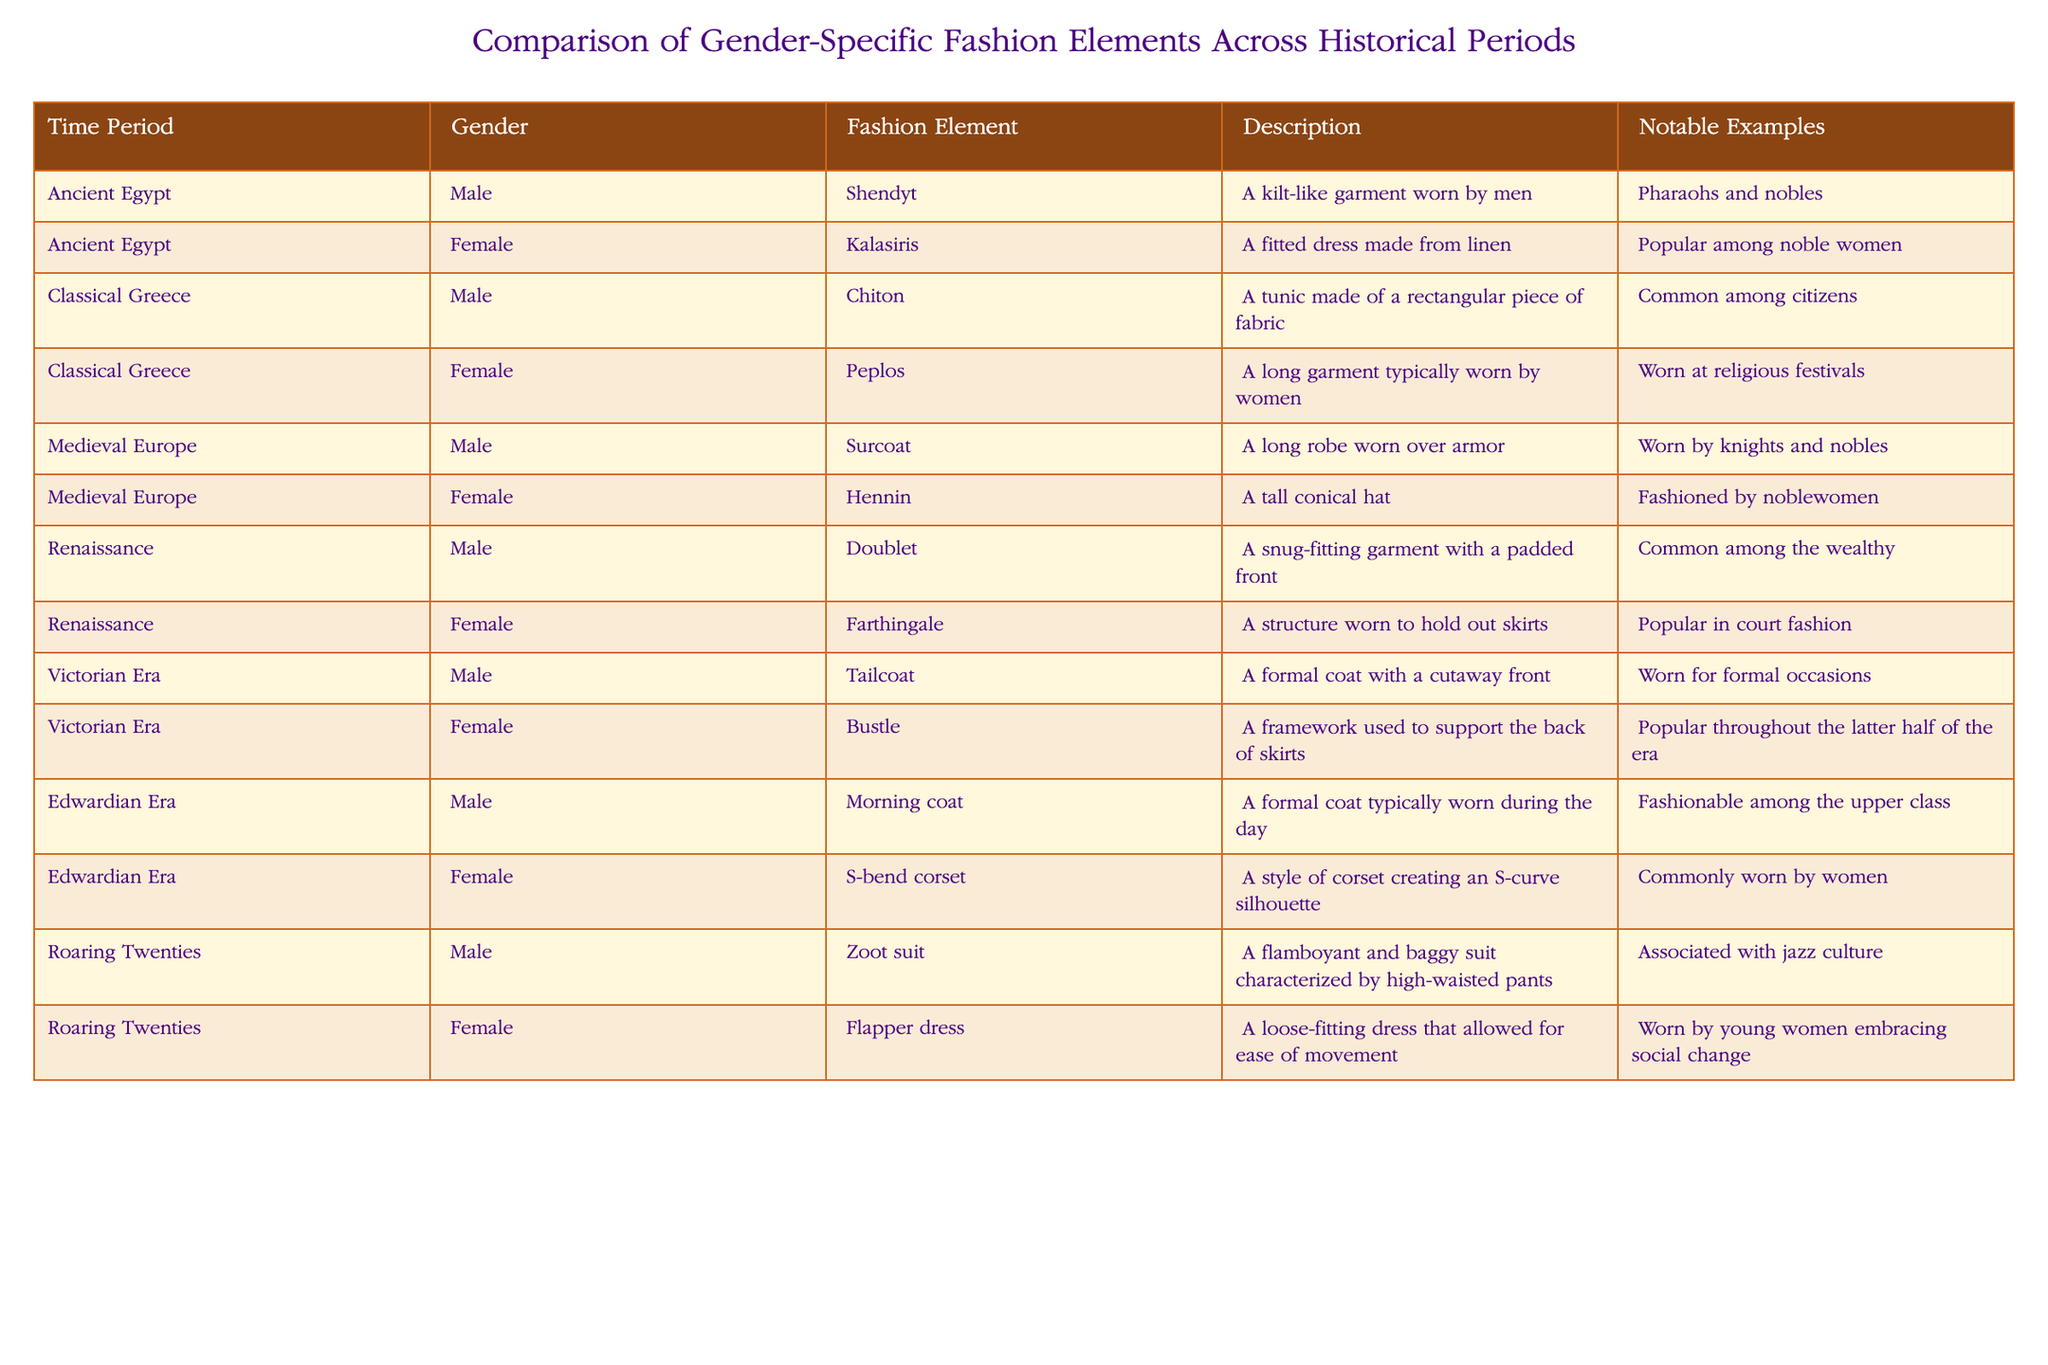What fashion element was worn by noblewomen in Ancient Egypt? According to the table, the fashion element worn by noblewomen in Ancient Egypt is the Kalasiris. This is directly stated in the table row corresponding to Ancient Egypt under the Female category.
Answer: Kalasiris Which gender wore a Zoot suit in the Roaring Twenties? From the table, it is clear that a Zoot suit was worn by males during the Roaring Twenties. This information is found in the row that represents the Roaring Twenties under the Male category.
Answer: Male How many unique fashion elements are listed for Medieval Europe? In the table, there are two entries specifically for Medieval Europe; one for male (Surcoat) and one for female (Hennin). Counting these gives a total of two unique fashion elements from that period.
Answer: 2 True or false: The Farthingale was a fashion element used by men during the Renaissance. The table indicates that the Farthingale was worn by females in the Renaissance. Since it is not associated with men, the statement is false.
Answer: False What is the main characteristic of the Flapper dress? The Flapper dress is described in the table as a loose-fitting dress that allowed for ease of movement, emphasizing its practicality and modern style during the Roaring Twenties.
Answer: Loose-fitting and allows ease of movement What are the notable examples of garments worn by the upper class in the Victorian Era? The table lists the Victorian Era fashion element for males as the Tailcoat and for females as the Bustle. Both were noted as worn for formal occasions and by people of higher social status, indicating their association with the upper class.
Answer: Tailcoat and Bustle How do the fashion elements for females compare between the Victorian Era and the Edwardian Era in terms of structure? In the Victorian Era, the Bustle is noted as a framework used to support skirts, whereas in the Edwardian Era, the S-bend corset is designed to create an S-curve silhouette. While both elements enhance a woman's shape, they do so in quite distinct ways, with the Bustle focusing on volume at the back and the S-bend corset focusing on creating specific body contours.
Answer: Different structural focus: Bustle for volume, S-bend corset for contour What fashion element is associated with jazz culture during the Roaring Twenties? The fashion element associated with jazz culture during the Roaring Twenties is the Zoot suit. This connection is made explicitly in the description provided in the table for males during this time period.
Answer: Zoot suit 